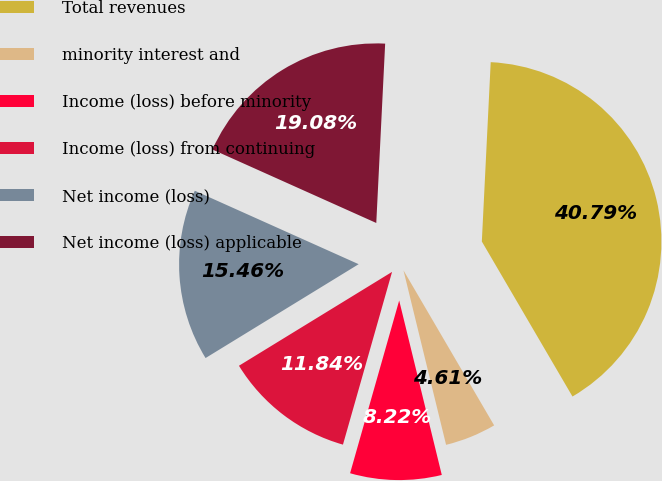<chart> <loc_0><loc_0><loc_500><loc_500><pie_chart><fcel>Total revenues<fcel>minority interest and<fcel>Income (loss) before minority<fcel>Income (loss) from continuing<fcel>Net income (loss)<fcel>Net income (loss) applicable<nl><fcel>40.79%<fcel>4.61%<fcel>8.22%<fcel>11.84%<fcel>15.46%<fcel>19.08%<nl></chart> 